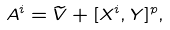Convert formula to latex. <formula><loc_0><loc_0><loc_500><loc_500>A ^ { i } = \widetilde { V } + [ X ^ { i } , Y ] ^ { p } ,</formula> 